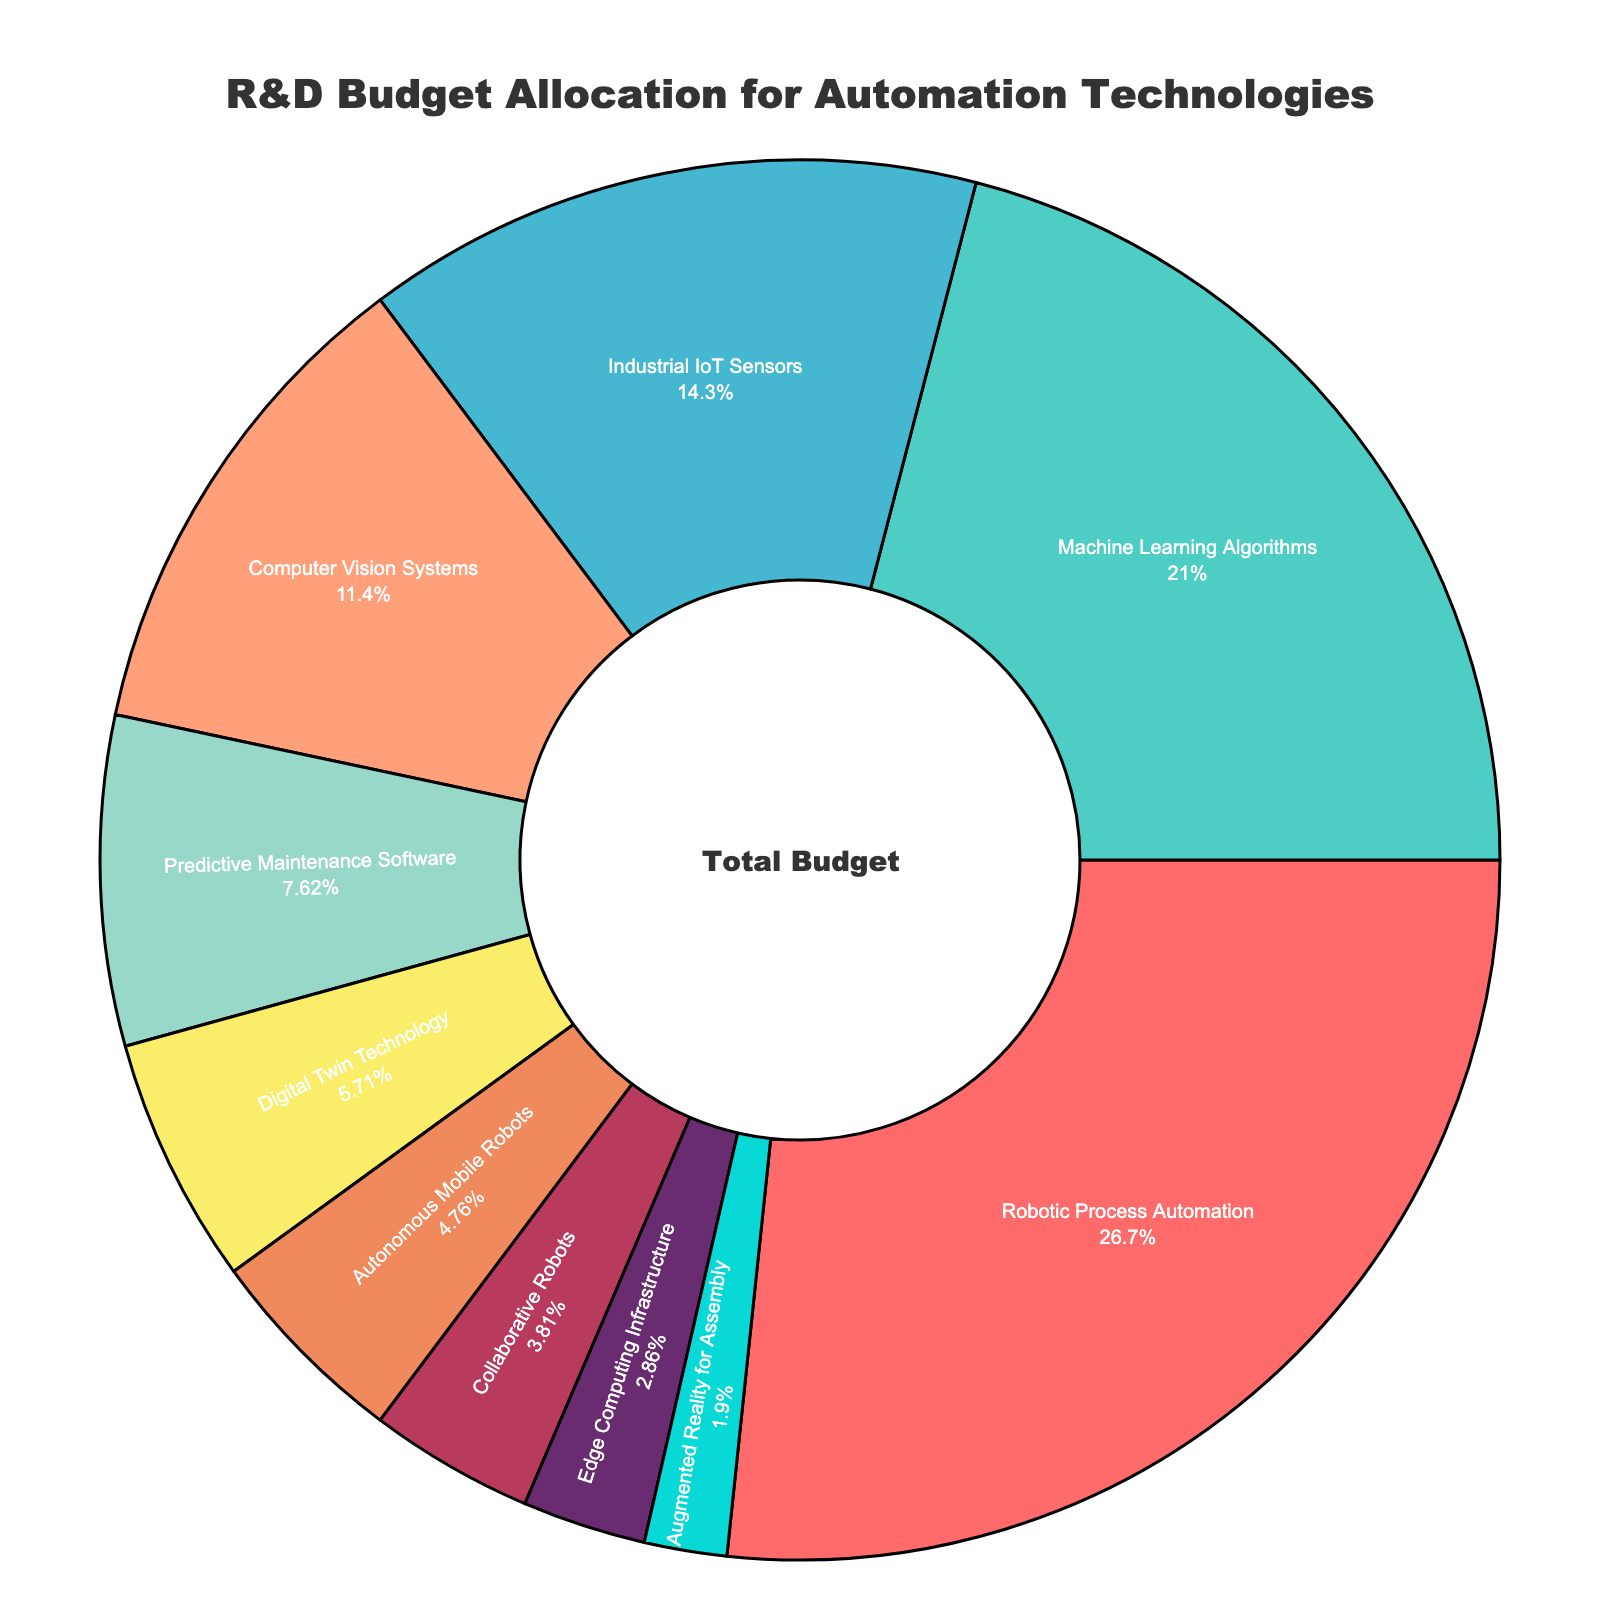What is the largest allocation of the R&D budget? The largest allocation can be determined by identifying the technology with the highest budget percentage. In this case, Robotic Process Automation has the highest percentage at 28%.
Answer: Robotic Process Automation Which technology has the smallest allocation of the R&D budget? The smallest allocation is identified by finding the technology with the lowest budget percentage. Augmented Reality for Assembly has the smallest allocation at 2%.
Answer: Augmented Reality for Assembly What is the combined budget percentage for Computer Vision Systems and Predictive Maintenance Software? To find the combined budget, add the percentages of Computer Vision Systems and Predictive Maintenance Software. 12% (Computer Vision Systems) + 8% (Predictive Maintenance Software) = 20%
Answer: 20% Which technology has a higher allocation: Machine Learning Algorithms or Digital Twin Technology? By comparing the percentages, Machine Learning Algorithms (22%) has a higher allocation than Digital Twin Technology (6%).
Answer: Machine Learning Algorithms What is the total budget percentage for all technologies that have a budget percentage less than 10%? Sum the percentages of Predictive Maintenance Software (8%), Digital Twin Technology (6%), Autonomous Mobile Robots (5%), Collaborative Robots (4%), Edge Computing Infrastructure (3%), and Augmented Reality for Assembly (2%): 8% + 6% + 5% + 4% + 3% + 2% = 28%
Answer: 28% How much greater is the budget percentage for Robotic Process Automation compared to Machine Learning Algorithms? Subtract the percentage of Machine Learning Algorithms from that of Robotic Process Automation: 28% - 22% = 6%
Answer: 6% What are the two technologies with the closest budget percentages? By comparing the percentages, Collaborative Robots (4%) and Edge Computing Infrastructure (3%) have the closest budget percentages with only a 1% difference.
Answer: Collaborative Robots and Edge Computing Infrastructure What is the median budget percentage of all listed technologies? Arrange the percentages in ascending order: 2%, 3%, 4%, 5%, 6%, 8%, 12%, 15%, 22%, 28%. The median is the average of the 5th and 6th values since there is an even number of values: (6% + 8%) / 2 = 7%
Answer: 7% Which technology is allocated exactly 15% of the R&D budget? By referring to the given data, Industrial IoT Sensors is allocated exactly 15% of the R&D budget.
Answer: Industrial IoT Sensors Combine the budget shares of the top three technologies. What percentage of the total budget do they represent? Sum the percentages of the top three technologies: Robotic Process Automation (28%), Machine Learning Algorithms (22%), and Industrial IoT Sensors (15%): 28% + 22% + 15% = 65%
Answer: 65% 